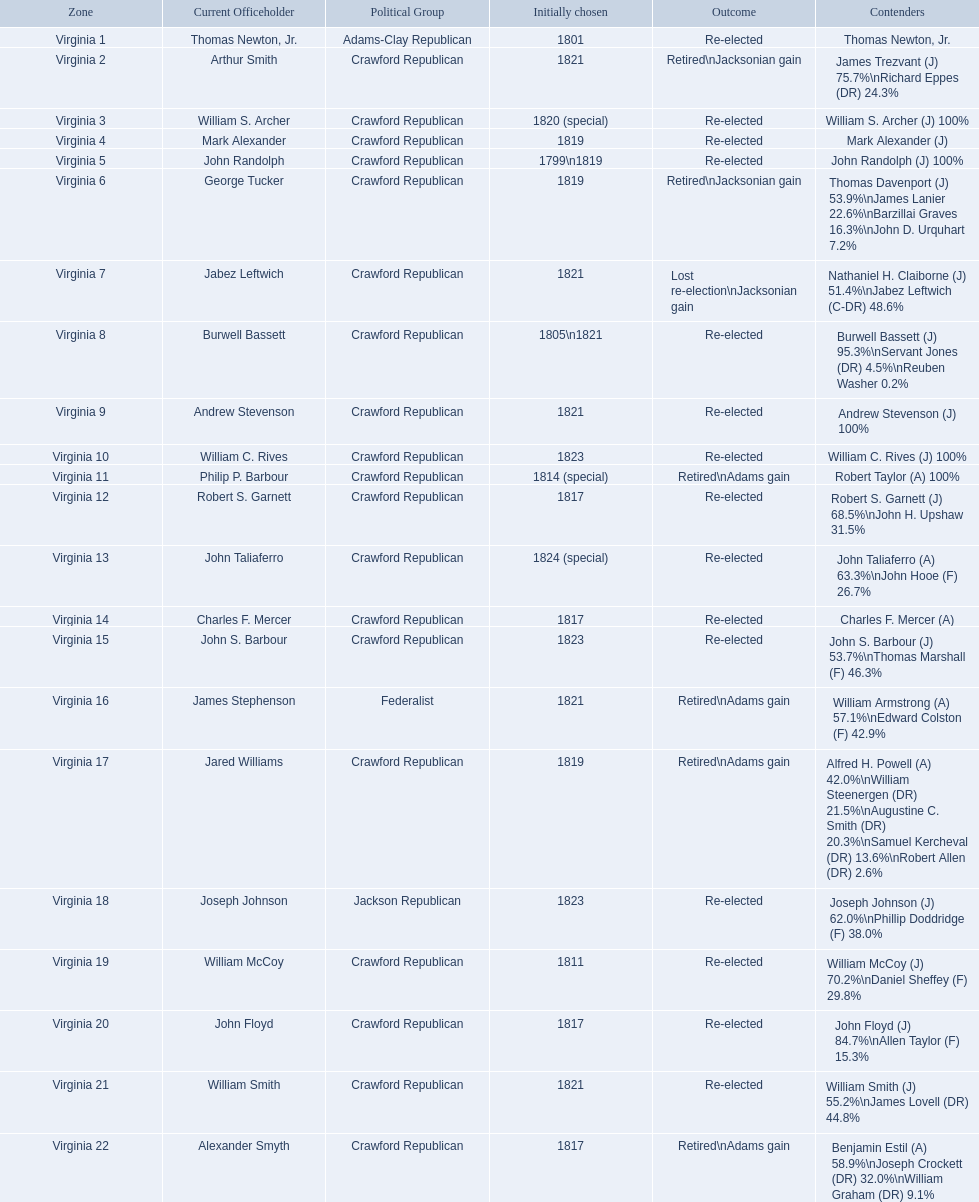Who were the incumbents of the 1824 united states house of representatives elections? Thomas Newton, Jr., Arthur Smith, William S. Archer, Mark Alexander, John Randolph, George Tucker, Jabez Leftwich, Burwell Bassett, Andrew Stevenson, William C. Rives, Philip P. Barbour, Robert S. Garnett, John Taliaferro, Charles F. Mercer, John S. Barbour, James Stephenson, Jared Williams, Joseph Johnson, William McCoy, John Floyd, William Smith, Alexander Smyth. And who were the candidates? Thomas Newton, Jr., James Trezvant (J) 75.7%\nRichard Eppes (DR) 24.3%, William S. Archer (J) 100%, Mark Alexander (J), John Randolph (J) 100%, Thomas Davenport (J) 53.9%\nJames Lanier 22.6%\nBarzillai Graves 16.3%\nJohn D. Urquhart 7.2%, Nathaniel H. Claiborne (J) 51.4%\nJabez Leftwich (C-DR) 48.6%, Burwell Bassett (J) 95.3%\nServant Jones (DR) 4.5%\nReuben Washer 0.2%, Andrew Stevenson (J) 100%, William C. Rives (J) 100%, Robert Taylor (A) 100%, Robert S. Garnett (J) 68.5%\nJohn H. Upshaw 31.5%, John Taliaferro (A) 63.3%\nJohn Hooe (F) 26.7%, Charles F. Mercer (A), John S. Barbour (J) 53.7%\nThomas Marshall (F) 46.3%, William Armstrong (A) 57.1%\nEdward Colston (F) 42.9%, Alfred H. Powell (A) 42.0%\nWilliam Steenergen (DR) 21.5%\nAugustine C. Smith (DR) 20.3%\nSamuel Kercheval (DR) 13.6%\nRobert Allen (DR) 2.6%, Joseph Johnson (J) 62.0%\nPhillip Doddridge (F) 38.0%, William McCoy (J) 70.2%\nDaniel Sheffey (F) 29.8%, John Floyd (J) 84.7%\nAllen Taylor (F) 15.3%, William Smith (J) 55.2%\nJames Lovell (DR) 44.8%, Benjamin Estil (A) 58.9%\nJoseph Crockett (DR) 32.0%\nWilliam Graham (DR) 9.1%. What were the results of their elections? Re-elected, Retired\nJacksonian gain, Re-elected, Re-elected, Re-elected, Retired\nJacksonian gain, Lost re-election\nJacksonian gain, Re-elected, Re-elected, Re-elected, Retired\nAdams gain, Re-elected, Re-elected, Re-elected, Re-elected, Retired\nAdams gain, Retired\nAdams gain, Re-elected, Re-elected, Re-elected, Re-elected, Retired\nAdams gain. And which jacksonian won over 76%? Arthur Smith. 